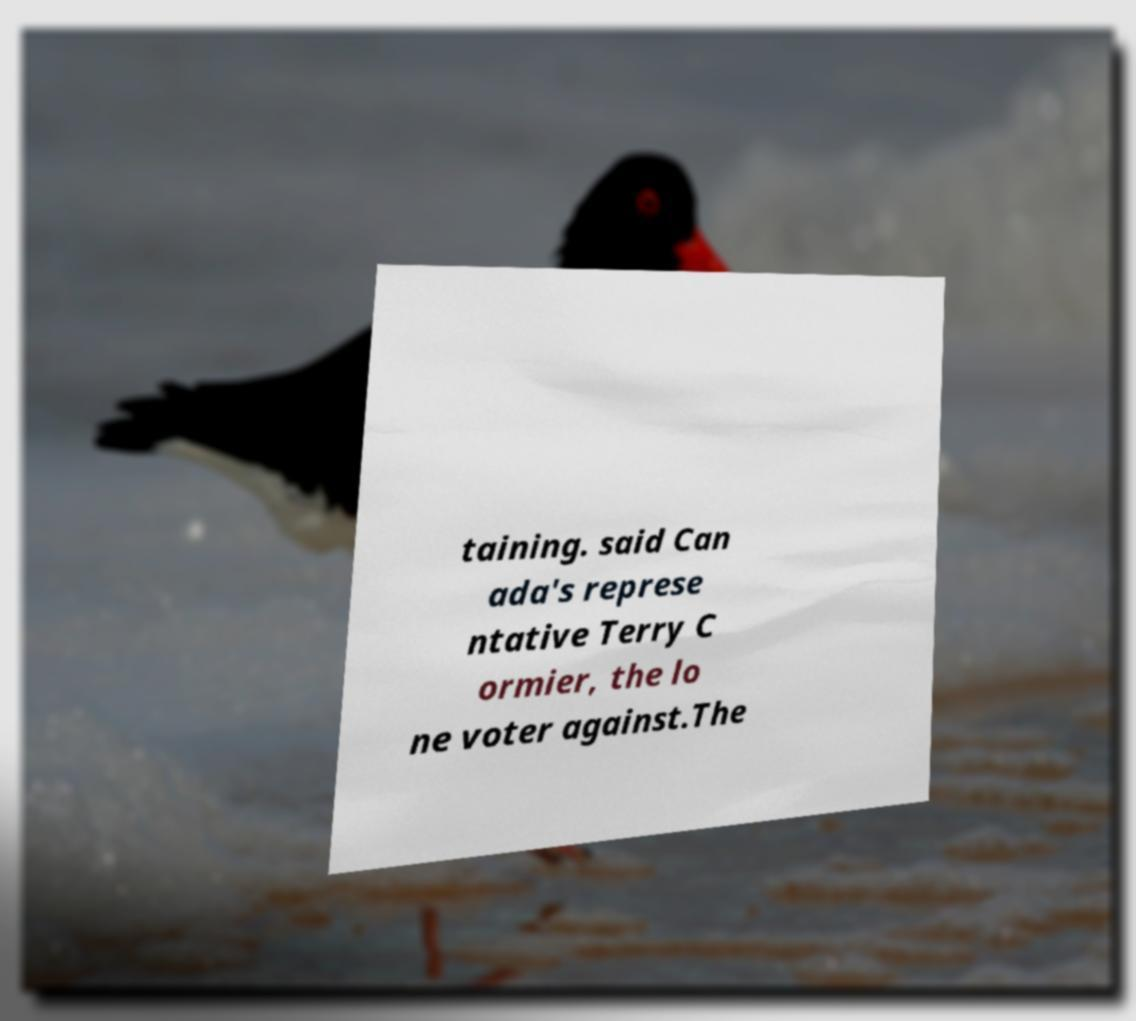There's text embedded in this image that I need extracted. Can you transcribe it verbatim? taining. said Can ada's represe ntative Terry C ormier, the lo ne voter against.The 